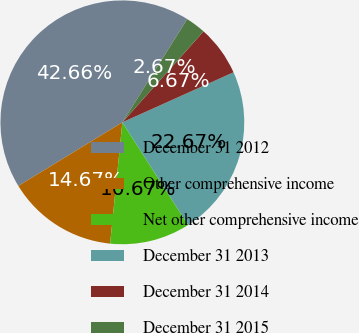Convert chart. <chart><loc_0><loc_0><loc_500><loc_500><pie_chart><fcel>December 31 2012<fcel>Other comprehensive income<fcel>Net other comprehensive income<fcel>December 31 2013<fcel>December 31 2014<fcel>December 31 2015<nl><fcel>42.67%<fcel>14.67%<fcel>10.67%<fcel>22.67%<fcel>6.67%<fcel>2.67%<nl></chart> 